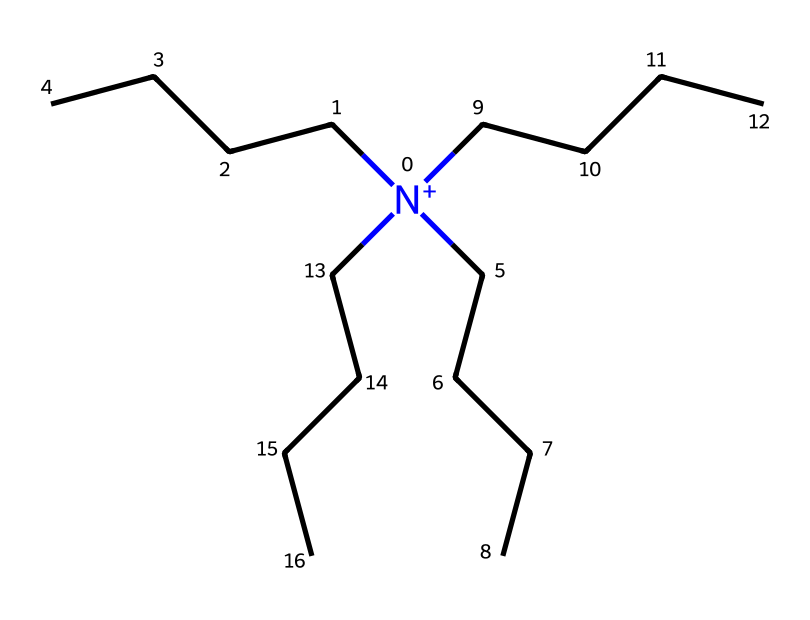What is the primary functional group in this chemical? The primary functional group in this chemical is the quaternary ammonium group, indicated by the nitrogen atom bonded to four alkyl chains.
Answer: quaternary ammonium How many carbon atoms are in this molecule? By counting the carbon atoms from each alkyl chain (4 chains each with 4 carbon atoms), there are a total of 16 carbon atoms.
Answer: 16 What type of surfactant is represented by this chemical structure? This chemical structure is indicative of a cationic surfactant because of the positively charged nitrogen at its core, which is typical for quaternary ammonium compounds.
Answer: cationic What property does the quaternary ammonium compound impart to fabric softeners? The presence of the quaternary ammonium compound leads to softening and antistatic properties in fabrics, which minimizes static cling and enhances feel and fluffiness.
Answer: softening How many hydrogen atoms are associated with the nitrogen in this chemical? The nitrogen in this structure does not have any hydrogens attached as it is bonded to four alkyl groups, thus satisfying its tetravalent nature.
Answer: 0 